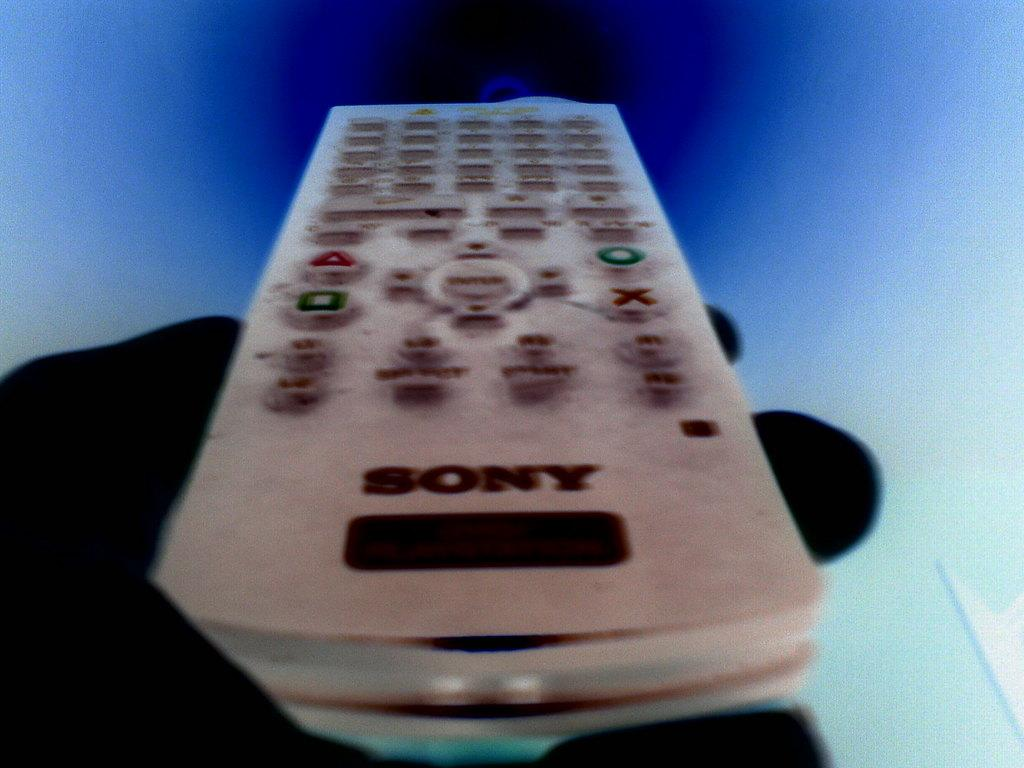<image>
Write a terse but informative summary of the picture. the sony remote control is white with white buttons 